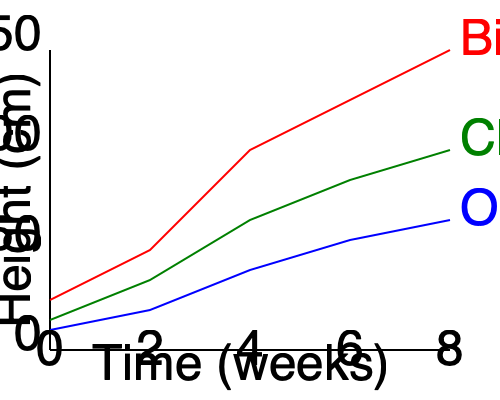The graph shows the growth rates of three exotic vegetables over 8 weeks. Which vegetable has the fastest growth rate, and by approximately how many centimeters does it outgrow the slowest-growing vegetable by the end of the 8-week period? To solve this problem, we need to follow these steps:

1. Identify the fastest and slowest growing vegetables:
   - Bitter Melon (red line) has the steepest slope, indicating the fastest growth.
   - Oca (blue line) has the least steep slope, indicating the slowest growth.

2. Determine the final heights at 8 weeks:
   - Bitter Melon: approximately 150 cm
   - Oca: approximately 65 cm

3. Calculate the difference in height:
   $150 \text{ cm} - 65 \text{ cm} = 85 \text{ cm}$

Therefore, Bitter Melon is the fastest-growing vegetable, and it outgrows Oca by approximately 85 cm by the end of the 8-week period.
Answer: Bitter Melon; 85 cm 